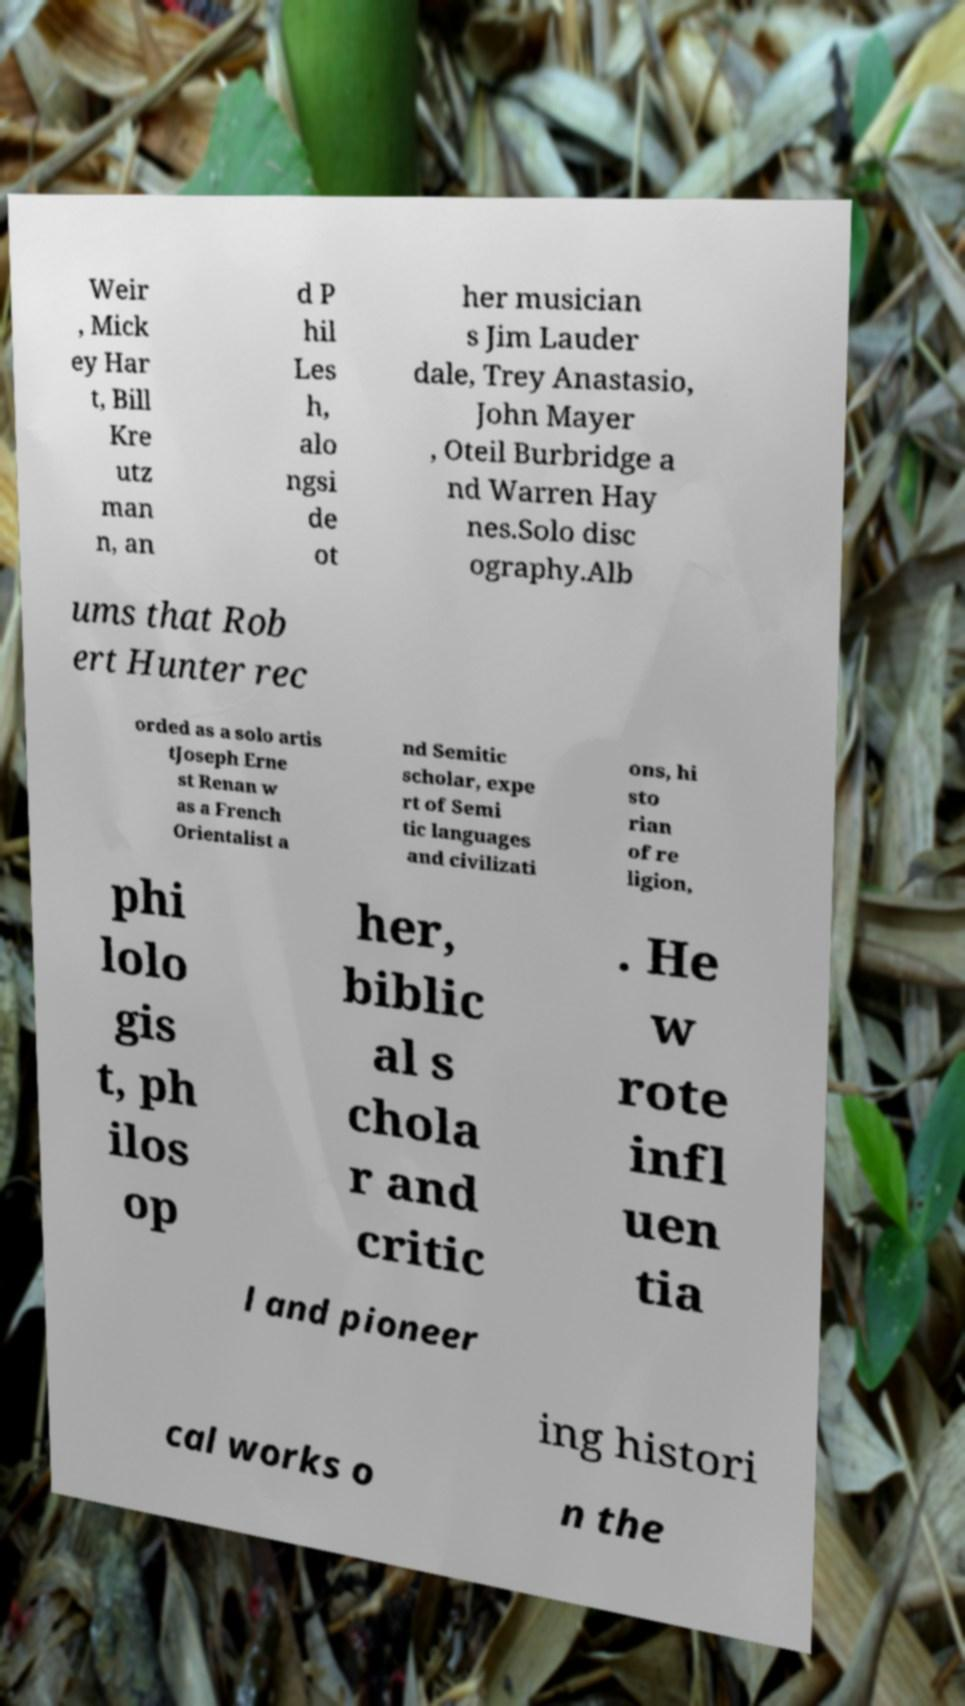Please identify and transcribe the text found in this image. Weir , Mick ey Har t, Bill Kre utz man n, an d P hil Les h, alo ngsi de ot her musician s Jim Lauder dale, Trey Anastasio, John Mayer , Oteil Burbridge a nd Warren Hay nes.Solo disc ography.Alb ums that Rob ert Hunter rec orded as a solo artis tJoseph Erne st Renan w as a French Orientalist a nd Semitic scholar, expe rt of Semi tic languages and civilizati ons, hi sto rian of re ligion, phi lolo gis t, ph ilos op her, biblic al s chola r and critic . He w rote infl uen tia l and pioneer ing histori cal works o n the 